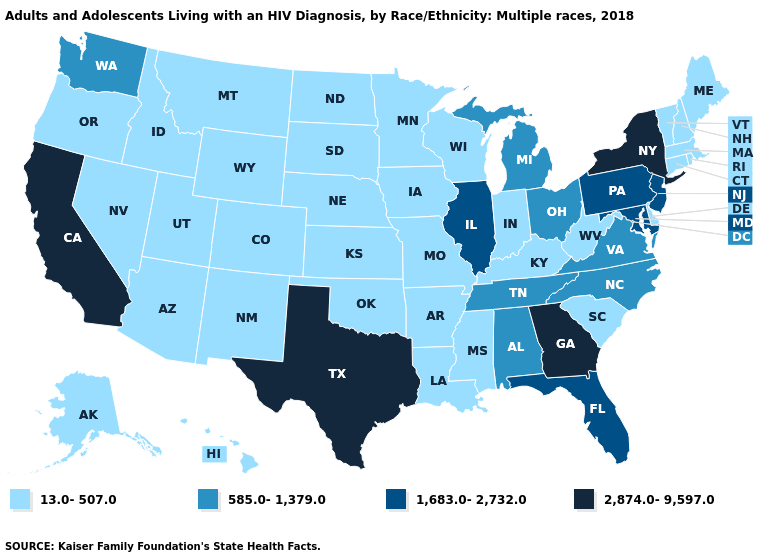Name the states that have a value in the range 585.0-1,379.0?
Write a very short answer. Alabama, Michigan, North Carolina, Ohio, Tennessee, Virginia, Washington. Name the states that have a value in the range 585.0-1,379.0?
Write a very short answer. Alabama, Michigan, North Carolina, Ohio, Tennessee, Virginia, Washington. How many symbols are there in the legend?
Answer briefly. 4. What is the value of Louisiana?
Answer briefly. 13.0-507.0. What is the value of Montana?
Quick response, please. 13.0-507.0. Name the states that have a value in the range 13.0-507.0?
Short answer required. Alaska, Arizona, Arkansas, Colorado, Connecticut, Delaware, Hawaii, Idaho, Indiana, Iowa, Kansas, Kentucky, Louisiana, Maine, Massachusetts, Minnesota, Mississippi, Missouri, Montana, Nebraska, Nevada, New Hampshire, New Mexico, North Dakota, Oklahoma, Oregon, Rhode Island, South Carolina, South Dakota, Utah, Vermont, West Virginia, Wisconsin, Wyoming. Among the states that border Oklahoma , which have the lowest value?
Be succinct. Arkansas, Colorado, Kansas, Missouri, New Mexico. How many symbols are there in the legend?
Keep it brief. 4. Does the first symbol in the legend represent the smallest category?
Give a very brief answer. Yes. Name the states that have a value in the range 1,683.0-2,732.0?
Short answer required. Florida, Illinois, Maryland, New Jersey, Pennsylvania. Does Utah have the lowest value in the West?
Concise answer only. Yes. Name the states that have a value in the range 1,683.0-2,732.0?
Give a very brief answer. Florida, Illinois, Maryland, New Jersey, Pennsylvania. Is the legend a continuous bar?
Short answer required. No. What is the highest value in states that border Wisconsin?
Be succinct. 1,683.0-2,732.0. 